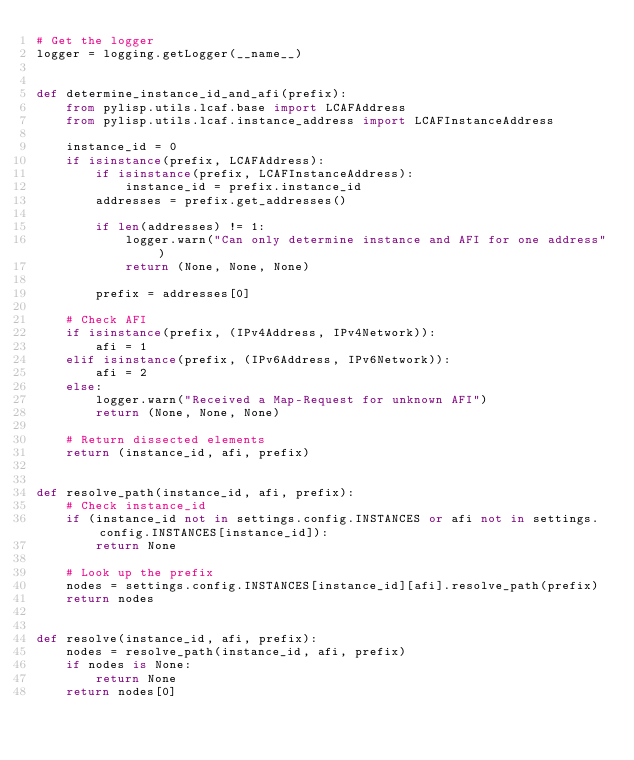<code> <loc_0><loc_0><loc_500><loc_500><_Python_># Get the logger
logger = logging.getLogger(__name__)


def determine_instance_id_and_afi(prefix):
    from pylisp.utils.lcaf.base import LCAFAddress
    from pylisp.utils.lcaf.instance_address import LCAFInstanceAddress

    instance_id = 0
    if isinstance(prefix, LCAFAddress):
        if isinstance(prefix, LCAFInstanceAddress):
            instance_id = prefix.instance_id
        addresses = prefix.get_addresses()

        if len(addresses) != 1:
            logger.warn("Can only determine instance and AFI for one address")
            return (None, None, None)

        prefix = addresses[0]

    # Check AFI
    if isinstance(prefix, (IPv4Address, IPv4Network)):
        afi = 1
    elif isinstance(prefix, (IPv6Address, IPv6Network)):
        afi = 2
    else:
        logger.warn("Received a Map-Request for unknown AFI")
        return (None, None, None)

    # Return dissected elements
    return (instance_id, afi, prefix)


def resolve_path(instance_id, afi, prefix):
    # Check instance_id
    if (instance_id not in settings.config.INSTANCES or afi not in settings.config.INSTANCES[instance_id]):
        return None

    # Look up the prefix
    nodes = settings.config.INSTANCES[instance_id][afi].resolve_path(prefix)
    return nodes


def resolve(instance_id, afi, prefix):
    nodes = resolve_path(instance_id, afi, prefix)
    if nodes is None:
        return None
    return nodes[0]
</code> 